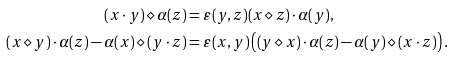Convert formula to latex. <formula><loc_0><loc_0><loc_500><loc_500>( x \cdot y ) \diamond \alpha ( z ) & = \varepsilon ( y , z ) ( x \diamond z ) \cdot \alpha ( y ) , \\ ( x \diamond y ) \cdot \alpha ( z ) - \alpha ( x ) \diamond ( y \cdot z ) & = \varepsilon ( x , y ) \left ( ( y \diamond x ) \cdot \alpha ( z ) - \alpha ( y ) \diamond ( x \cdot z ) \right ) .</formula> 